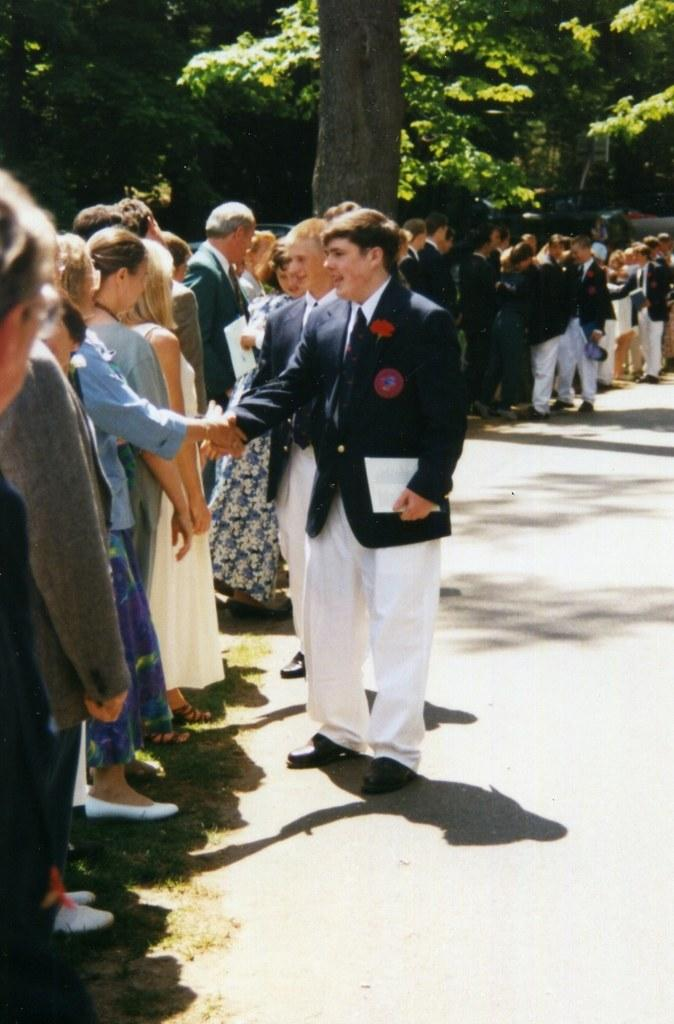How many people can be seen in the image? There are a few people in the image. What can be seen under the people's feet? The ground is visible in the image. What type of natural elements are present in the image? There are trees in the image. What type of texture can be seen on the houses in the image? There are no houses present in the image. How does the railway system function in the image? There is no railway system present in the image. 